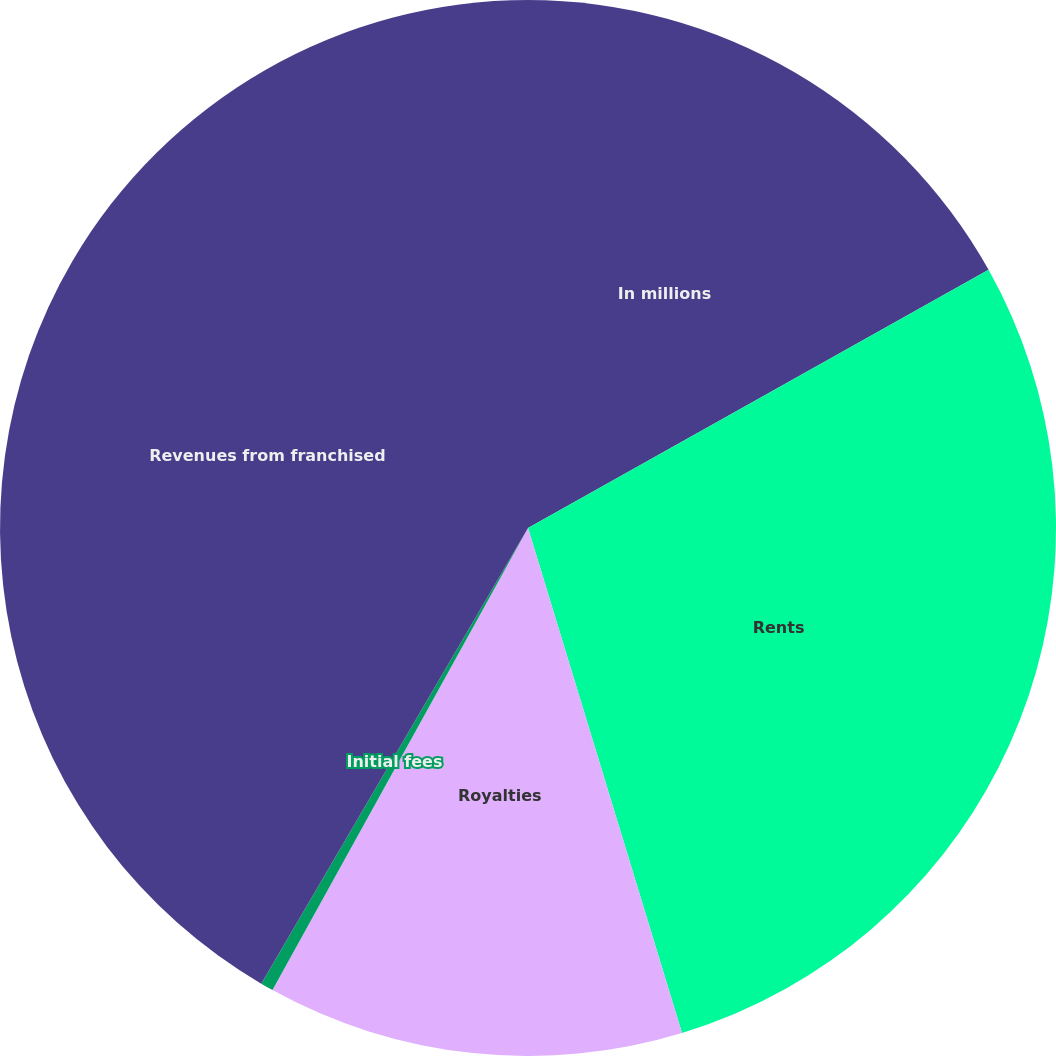Convert chart. <chart><loc_0><loc_0><loc_500><loc_500><pie_chart><fcel>In millions<fcel>Rents<fcel>Royalties<fcel>Initial fees<fcel>Revenues from franchised<nl><fcel>16.87%<fcel>28.42%<fcel>12.75%<fcel>0.39%<fcel>41.57%<nl></chart> 